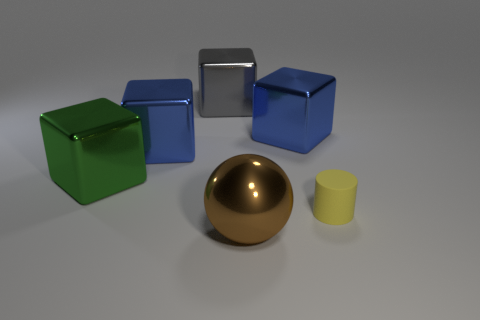How many objects are either small green things or gray blocks?
Your response must be concise. 1. Are there any other things that have the same material as the tiny cylinder?
Your answer should be very brief. No. Is there a thing?
Keep it short and to the point. Yes. Is the material of the cube right of the big gray thing the same as the yellow object?
Offer a terse response. No. Is there a tiny red thing that has the same shape as the green thing?
Your answer should be compact. No. Is the number of tiny matte cylinders that are behind the gray shiny block the same as the number of large cyan shiny cylinders?
Your answer should be compact. Yes. What is the large blue thing that is to the left of the large shiny thing in front of the green object made of?
Your answer should be compact. Metal. The yellow thing is what shape?
Your answer should be compact. Cylinder. Are there the same number of large blue metallic things in front of the big brown thing and small objects left of the rubber cylinder?
Make the answer very short. Yes. There is a metal thing in front of the big green object; is it the same color as the large object that is to the right of the big brown metal object?
Provide a succinct answer. No. 